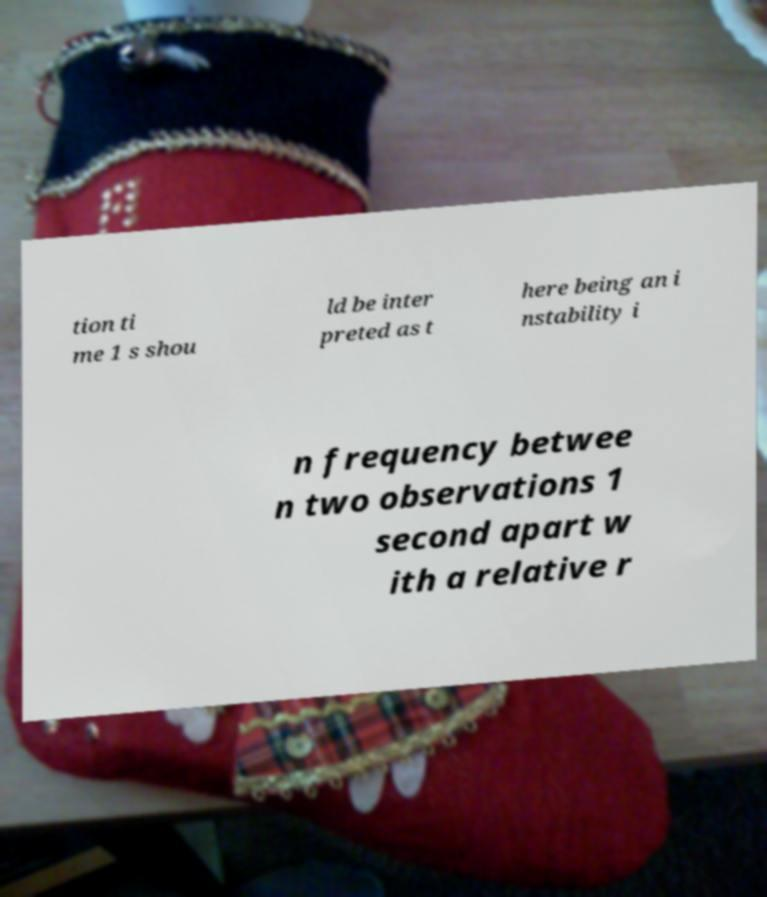Please read and relay the text visible in this image. What does it say? tion ti me 1 s shou ld be inter preted as t here being an i nstability i n frequency betwee n two observations 1 second apart w ith a relative r 